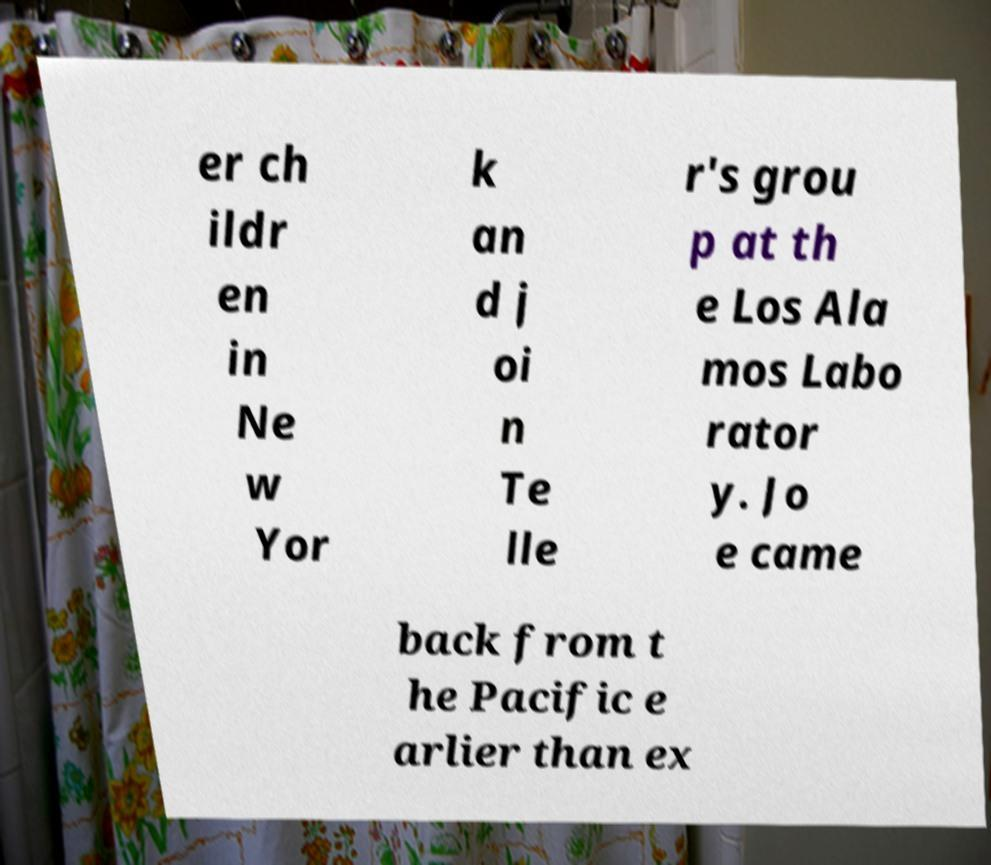Could you extract and type out the text from this image? er ch ildr en in Ne w Yor k an d j oi n Te lle r's grou p at th e Los Ala mos Labo rator y. Jo e came back from t he Pacific e arlier than ex 